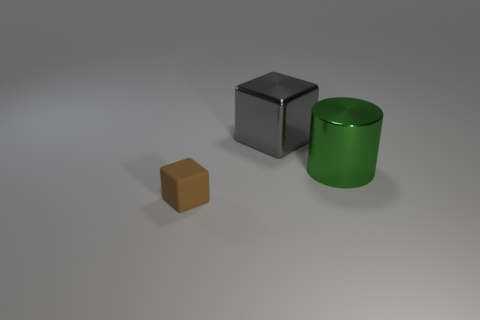Add 3 red rubber cubes. How many objects exist? 6 Subtract all cylinders. How many objects are left? 2 Subtract 0 blue balls. How many objects are left? 3 Subtract all big yellow balls. Subtract all gray blocks. How many objects are left? 2 Add 2 gray shiny objects. How many gray shiny objects are left? 3 Add 1 metallic blocks. How many metallic blocks exist? 2 